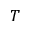<formula> <loc_0><loc_0><loc_500><loc_500>T</formula> 